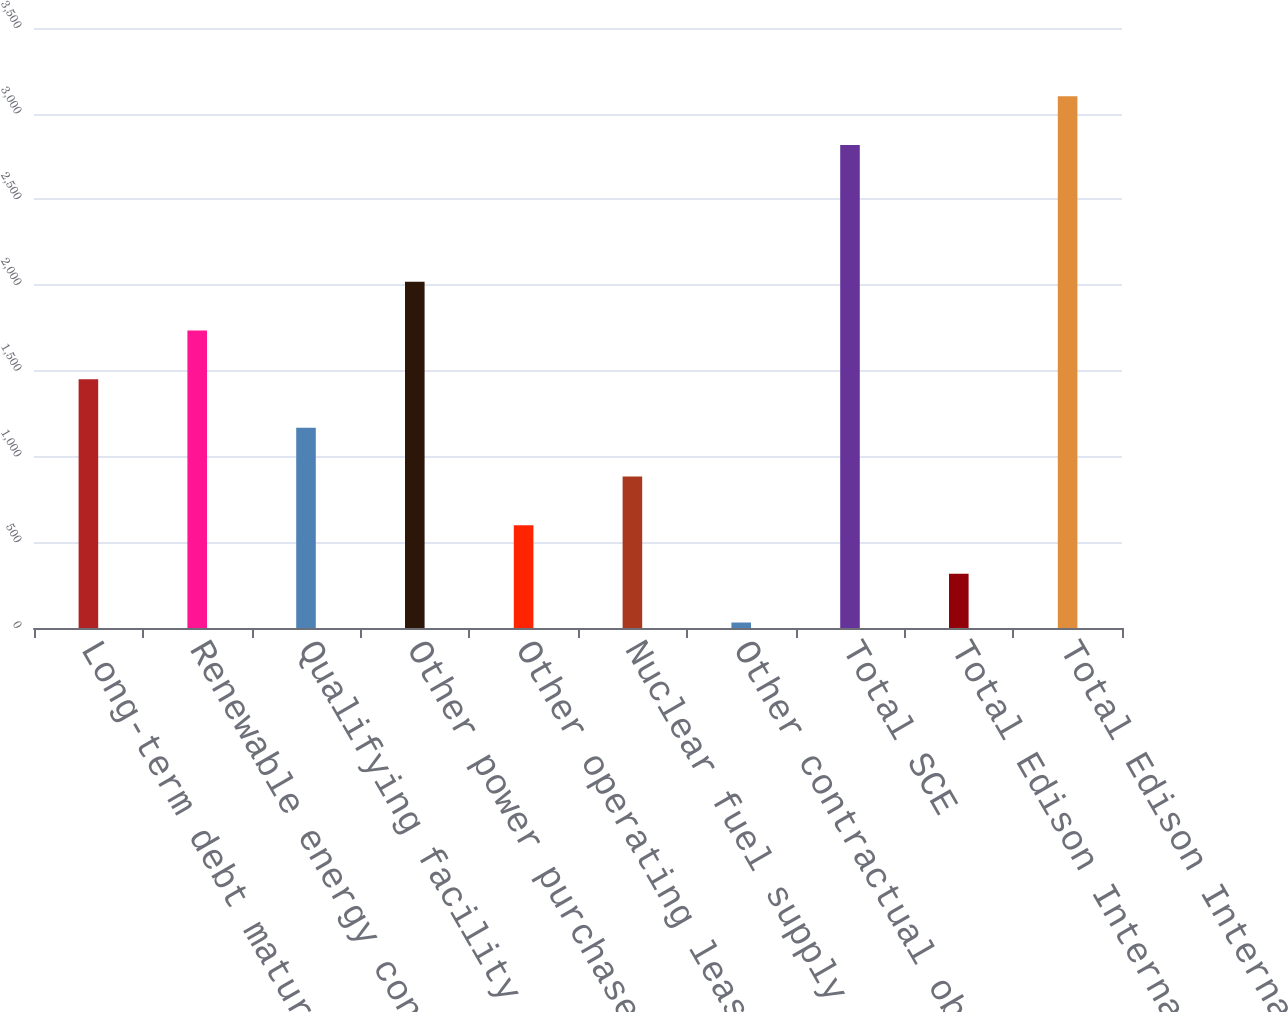Convert chart. <chart><loc_0><loc_0><loc_500><loc_500><bar_chart><fcel>Long-term debt maturities and<fcel>Renewable energy contracts<fcel>Qualifying facility contracts<fcel>Other power purchase<fcel>Other operating lease<fcel>Nuclear fuel supply contract<fcel>Other contractual obligations<fcel>Total SCE<fcel>Total Edison International<fcel>Total Edison International 78<nl><fcel>1451.5<fcel>1735.4<fcel>1167.6<fcel>2019.3<fcel>599.8<fcel>883.7<fcel>32<fcel>2818<fcel>315.9<fcel>3101.9<nl></chart> 